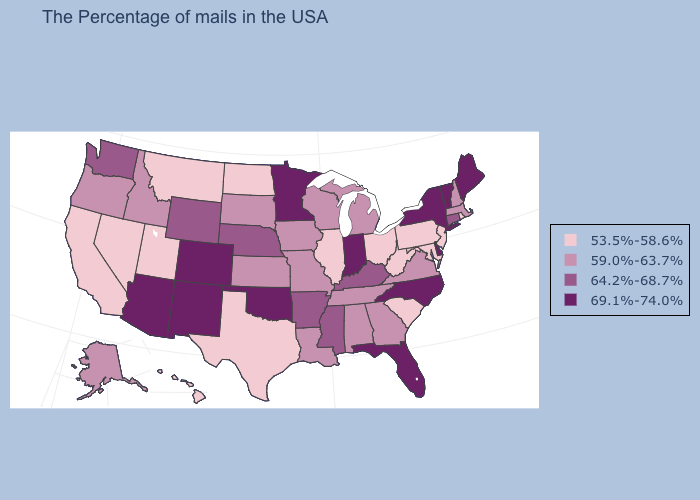Does Colorado have the highest value in the USA?
Be succinct. Yes. How many symbols are there in the legend?
Short answer required. 4. Which states have the lowest value in the USA?
Keep it brief. Rhode Island, New Jersey, Maryland, Pennsylvania, South Carolina, West Virginia, Ohio, Illinois, Texas, North Dakota, Utah, Montana, Nevada, California, Hawaii. Among the states that border Indiana , does Illinois have the highest value?
Give a very brief answer. No. What is the lowest value in the West?
Be succinct. 53.5%-58.6%. Name the states that have a value in the range 64.2%-68.7%?
Quick response, please. Connecticut, Kentucky, Mississippi, Arkansas, Nebraska, Wyoming, Washington. What is the value of Missouri?
Short answer required. 59.0%-63.7%. What is the value of Utah?
Give a very brief answer. 53.5%-58.6%. Does Massachusetts have the same value as Georgia?
Short answer required. Yes. Name the states that have a value in the range 69.1%-74.0%?
Keep it brief. Maine, Vermont, New York, Delaware, North Carolina, Florida, Indiana, Minnesota, Oklahoma, Colorado, New Mexico, Arizona. What is the lowest value in states that border Kansas?
Give a very brief answer. 59.0%-63.7%. Name the states that have a value in the range 53.5%-58.6%?
Concise answer only. Rhode Island, New Jersey, Maryland, Pennsylvania, South Carolina, West Virginia, Ohio, Illinois, Texas, North Dakota, Utah, Montana, Nevada, California, Hawaii. Name the states that have a value in the range 64.2%-68.7%?
Be succinct. Connecticut, Kentucky, Mississippi, Arkansas, Nebraska, Wyoming, Washington. Name the states that have a value in the range 53.5%-58.6%?
Short answer required. Rhode Island, New Jersey, Maryland, Pennsylvania, South Carolina, West Virginia, Ohio, Illinois, Texas, North Dakota, Utah, Montana, Nevada, California, Hawaii. 